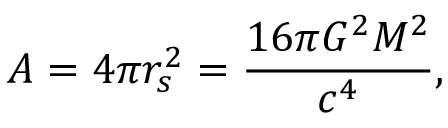Convert formula to latex. <formula><loc_0><loc_0><loc_500><loc_500>A = 4 \pi r _ { s } ^ { 2 } = { \frac { 1 6 \pi G ^ { 2 } M ^ { 2 } } { c ^ { 4 } } } ,</formula> 